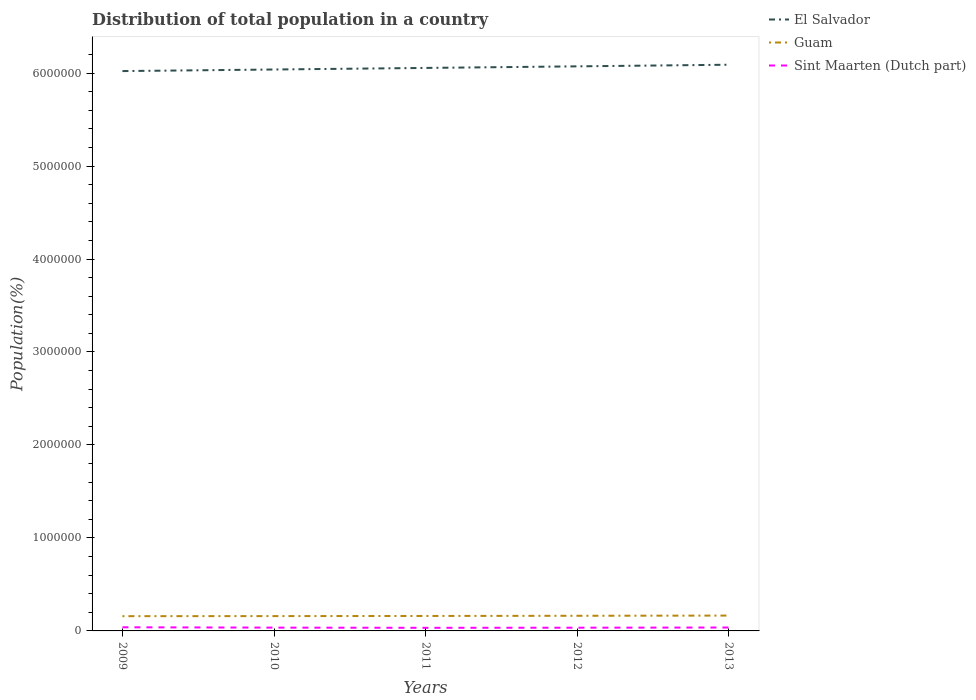How many different coloured lines are there?
Provide a succinct answer. 3. Is the number of lines equal to the number of legend labels?
Make the answer very short. Yes. Across all years, what is the maximum population of in El Salvador?
Keep it short and to the point. 6.02e+06. In which year was the population of in El Salvador maximum?
Your response must be concise. 2009. What is the total population of in Guam in the graph?
Offer a terse response. -4186. What is the difference between the highest and the second highest population of in Sint Maarten (Dutch part)?
Offer a very short reply. 5698. What is the difference between the highest and the lowest population of in El Salvador?
Your answer should be compact. 2. Is the population of in Sint Maarten (Dutch part) strictly greater than the population of in Guam over the years?
Give a very brief answer. Yes. What is the difference between two consecutive major ticks on the Y-axis?
Your response must be concise. 1.00e+06. Are the values on the major ticks of Y-axis written in scientific E-notation?
Keep it short and to the point. No. Where does the legend appear in the graph?
Provide a short and direct response. Top right. What is the title of the graph?
Offer a terse response. Distribution of total population in a country. Does "Saudi Arabia" appear as one of the legend labels in the graph?
Offer a terse response. No. What is the label or title of the Y-axis?
Your answer should be compact. Population(%). What is the Population(%) of El Salvador in 2009?
Your response must be concise. 6.02e+06. What is the Population(%) of Guam in 2009?
Offer a very short reply. 1.59e+05. What is the Population(%) of Sint Maarten (Dutch part) in 2009?
Give a very brief answer. 3.91e+04. What is the Population(%) in El Salvador in 2010?
Provide a short and direct response. 6.04e+06. What is the Population(%) in Guam in 2010?
Ensure brevity in your answer.  1.59e+05. What is the Population(%) of Sint Maarten (Dutch part) in 2010?
Offer a terse response. 3.55e+04. What is the Population(%) of El Salvador in 2011?
Make the answer very short. 6.06e+06. What is the Population(%) in Guam in 2011?
Provide a short and direct response. 1.61e+05. What is the Population(%) in Sint Maarten (Dutch part) in 2011?
Your answer should be very brief. 3.34e+04. What is the Population(%) in El Salvador in 2012?
Keep it short and to the point. 6.07e+06. What is the Population(%) of Guam in 2012?
Your answer should be compact. 1.63e+05. What is the Population(%) in Sint Maarten (Dutch part) in 2012?
Ensure brevity in your answer.  3.46e+04. What is the Population(%) in El Salvador in 2013?
Ensure brevity in your answer.  6.09e+06. What is the Population(%) of Guam in 2013?
Your answer should be compact. 1.65e+05. What is the Population(%) in Sint Maarten (Dutch part) in 2013?
Provide a short and direct response. 3.66e+04. Across all years, what is the maximum Population(%) of El Salvador?
Offer a terse response. 6.09e+06. Across all years, what is the maximum Population(%) of Guam?
Provide a short and direct response. 1.65e+05. Across all years, what is the maximum Population(%) of Sint Maarten (Dutch part)?
Your answer should be very brief. 3.91e+04. Across all years, what is the minimum Population(%) of El Salvador?
Give a very brief answer. 6.02e+06. Across all years, what is the minimum Population(%) of Guam?
Provide a short and direct response. 1.59e+05. Across all years, what is the minimum Population(%) in Sint Maarten (Dutch part)?
Keep it short and to the point. 3.34e+04. What is the total Population(%) of El Salvador in the graph?
Your response must be concise. 3.03e+07. What is the total Population(%) of Guam in the graph?
Your response must be concise. 8.07e+05. What is the total Population(%) of Sint Maarten (Dutch part) in the graph?
Your response must be concise. 1.79e+05. What is the difference between the Population(%) of El Salvador in 2009 and that in 2010?
Give a very brief answer. -1.69e+04. What is the difference between the Population(%) in Guam in 2009 and that in 2010?
Ensure brevity in your answer.  -819. What is the difference between the Population(%) of Sint Maarten (Dutch part) in 2009 and that in 2010?
Your response must be concise. 3659. What is the difference between the Population(%) in El Salvador in 2009 and that in 2011?
Offer a terse response. -3.38e+04. What is the difference between the Population(%) in Guam in 2009 and that in 2011?
Offer a terse response. -2237. What is the difference between the Population(%) in Sint Maarten (Dutch part) in 2009 and that in 2011?
Ensure brevity in your answer.  5698. What is the difference between the Population(%) of El Salvador in 2009 and that in 2012?
Offer a terse response. -5.09e+04. What is the difference between the Population(%) in Guam in 2009 and that in 2012?
Your answer should be very brief. -4186. What is the difference between the Population(%) in Sint Maarten (Dutch part) in 2009 and that in 2012?
Provide a short and direct response. 4493. What is the difference between the Population(%) in El Salvador in 2009 and that in 2013?
Offer a very short reply. -6.83e+04. What is the difference between the Population(%) in Guam in 2009 and that in 2013?
Offer a very short reply. -6500. What is the difference between the Population(%) of Sint Maarten (Dutch part) in 2009 and that in 2013?
Your answer should be compact. 2526. What is the difference between the Population(%) in El Salvador in 2010 and that in 2011?
Offer a terse response. -1.69e+04. What is the difference between the Population(%) in Guam in 2010 and that in 2011?
Offer a very short reply. -1418. What is the difference between the Population(%) in Sint Maarten (Dutch part) in 2010 and that in 2011?
Provide a short and direct response. 2039. What is the difference between the Population(%) in El Salvador in 2010 and that in 2012?
Your answer should be compact. -3.39e+04. What is the difference between the Population(%) in Guam in 2010 and that in 2012?
Provide a succinct answer. -3367. What is the difference between the Population(%) of Sint Maarten (Dutch part) in 2010 and that in 2012?
Your response must be concise. 834. What is the difference between the Population(%) in El Salvador in 2010 and that in 2013?
Give a very brief answer. -5.13e+04. What is the difference between the Population(%) in Guam in 2010 and that in 2013?
Your answer should be very brief. -5681. What is the difference between the Population(%) of Sint Maarten (Dutch part) in 2010 and that in 2013?
Provide a short and direct response. -1133. What is the difference between the Population(%) of El Salvador in 2011 and that in 2012?
Make the answer very short. -1.70e+04. What is the difference between the Population(%) of Guam in 2011 and that in 2012?
Give a very brief answer. -1949. What is the difference between the Population(%) of Sint Maarten (Dutch part) in 2011 and that in 2012?
Your response must be concise. -1205. What is the difference between the Population(%) in El Salvador in 2011 and that in 2013?
Make the answer very short. -3.44e+04. What is the difference between the Population(%) in Guam in 2011 and that in 2013?
Make the answer very short. -4263. What is the difference between the Population(%) of Sint Maarten (Dutch part) in 2011 and that in 2013?
Provide a succinct answer. -3172. What is the difference between the Population(%) of El Salvador in 2012 and that in 2013?
Your response must be concise. -1.74e+04. What is the difference between the Population(%) of Guam in 2012 and that in 2013?
Offer a terse response. -2314. What is the difference between the Population(%) of Sint Maarten (Dutch part) in 2012 and that in 2013?
Ensure brevity in your answer.  -1967. What is the difference between the Population(%) of El Salvador in 2009 and the Population(%) of Guam in 2010?
Make the answer very short. 5.86e+06. What is the difference between the Population(%) of El Salvador in 2009 and the Population(%) of Sint Maarten (Dutch part) in 2010?
Ensure brevity in your answer.  5.99e+06. What is the difference between the Population(%) of Guam in 2009 and the Population(%) of Sint Maarten (Dutch part) in 2010?
Offer a terse response. 1.23e+05. What is the difference between the Population(%) of El Salvador in 2009 and the Population(%) of Guam in 2011?
Make the answer very short. 5.86e+06. What is the difference between the Population(%) of El Salvador in 2009 and the Population(%) of Sint Maarten (Dutch part) in 2011?
Give a very brief answer. 5.99e+06. What is the difference between the Population(%) of Guam in 2009 and the Population(%) of Sint Maarten (Dutch part) in 2011?
Offer a very short reply. 1.25e+05. What is the difference between the Population(%) in El Salvador in 2009 and the Population(%) in Guam in 2012?
Provide a succinct answer. 5.86e+06. What is the difference between the Population(%) of El Salvador in 2009 and the Population(%) of Sint Maarten (Dutch part) in 2012?
Offer a terse response. 5.99e+06. What is the difference between the Population(%) of Guam in 2009 and the Population(%) of Sint Maarten (Dutch part) in 2012?
Provide a succinct answer. 1.24e+05. What is the difference between the Population(%) in El Salvador in 2009 and the Population(%) in Guam in 2013?
Your answer should be compact. 5.86e+06. What is the difference between the Population(%) in El Salvador in 2009 and the Population(%) in Sint Maarten (Dutch part) in 2013?
Offer a very short reply. 5.98e+06. What is the difference between the Population(%) in Guam in 2009 and the Population(%) in Sint Maarten (Dutch part) in 2013?
Your answer should be compact. 1.22e+05. What is the difference between the Population(%) of El Salvador in 2010 and the Population(%) of Guam in 2011?
Provide a succinct answer. 5.88e+06. What is the difference between the Population(%) in El Salvador in 2010 and the Population(%) in Sint Maarten (Dutch part) in 2011?
Provide a short and direct response. 6.00e+06. What is the difference between the Population(%) of Guam in 2010 and the Population(%) of Sint Maarten (Dutch part) in 2011?
Give a very brief answer. 1.26e+05. What is the difference between the Population(%) of El Salvador in 2010 and the Population(%) of Guam in 2012?
Provide a succinct answer. 5.88e+06. What is the difference between the Population(%) of El Salvador in 2010 and the Population(%) of Sint Maarten (Dutch part) in 2012?
Your response must be concise. 6.00e+06. What is the difference between the Population(%) in Guam in 2010 and the Population(%) in Sint Maarten (Dutch part) in 2012?
Offer a very short reply. 1.25e+05. What is the difference between the Population(%) of El Salvador in 2010 and the Population(%) of Guam in 2013?
Your response must be concise. 5.87e+06. What is the difference between the Population(%) of El Salvador in 2010 and the Population(%) of Sint Maarten (Dutch part) in 2013?
Ensure brevity in your answer.  6.00e+06. What is the difference between the Population(%) of Guam in 2010 and the Population(%) of Sint Maarten (Dutch part) in 2013?
Your answer should be very brief. 1.23e+05. What is the difference between the Population(%) of El Salvador in 2011 and the Population(%) of Guam in 2012?
Make the answer very short. 5.89e+06. What is the difference between the Population(%) of El Salvador in 2011 and the Population(%) of Sint Maarten (Dutch part) in 2012?
Your response must be concise. 6.02e+06. What is the difference between the Population(%) in Guam in 2011 and the Population(%) in Sint Maarten (Dutch part) in 2012?
Offer a very short reply. 1.26e+05. What is the difference between the Population(%) in El Salvador in 2011 and the Population(%) in Guam in 2013?
Ensure brevity in your answer.  5.89e+06. What is the difference between the Population(%) in El Salvador in 2011 and the Population(%) in Sint Maarten (Dutch part) in 2013?
Your response must be concise. 6.02e+06. What is the difference between the Population(%) in Guam in 2011 and the Population(%) in Sint Maarten (Dutch part) in 2013?
Make the answer very short. 1.24e+05. What is the difference between the Population(%) in El Salvador in 2012 and the Population(%) in Guam in 2013?
Provide a succinct answer. 5.91e+06. What is the difference between the Population(%) in El Salvador in 2012 and the Population(%) in Sint Maarten (Dutch part) in 2013?
Offer a terse response. 6.04e+06. What is the difference between the Population(%) of Guam in 2012 and the Population(%) of Sint Maarten (Dutch part) in 2013?
Provide a short and direct response. 1.26e+05. What is the average Population(%) of El Salvador per year?
Offer a terse response. 6.06e+06. What is the average Population(%) in Guam per year?
Give a very brief answer. 1.61e+05. What is the average Population(%) of Sint Maarten (Dutch part) per year?
Give a very brief answer. 3.59e+04. In the year 2009, what is the difference between the Population(%) in El Salvador and Population(%) in Guam?
Your answer should be very brief. 5.86e+06. In the year 2009, what is the difference between the Population(%) in El Salvador and Population(%) in Sint Maarten (Dutch part)?
Provide a short and direct response. 5.98e+06. In the year 2009, what is the difference between the Population(%) of Guam and Population(%) of Sint Maarten (Dutch part)?
Give a very brief answer. 1.19e+05. In the year 2010, what is the difference between the Population(%) of El Salvador and Population(%) of Guam?
Your answer should be very brief. 5.88e+06. In the year 2010, what is the difference between the Population(%) of El Salvador and Population(%) of Sint Maarten (Dutch part)?
Provide a short and direct response. 6.00e+06. In the year 2010, what is the difference between the Population(%) in Guam and Population(%) in Sint Maarten (Dutch part)?
Provide a succinct answer. 1.24e+05. In the year 2011, what is the difference between the Population(%) of El Salvador and Population(%) of Guam?
Keep it short and to the point. 5.89e+06. In the year 2011, what is the difference between the Population(%) of El Salvador and Population(%) of Sint Maarten (Dutch part)?
Keep it short and to the point. 6.02e+06. In the year 2011, what is the difference between the Population(%) in Guam and Population(%) in Sint Maarten (Dutch part)?
Your response must be concise. 1.27e+05. In the year 2012, what is the difference between the Population(%) in El Salvador and Population(%) in Guam?
Your answer should be compact. 5.91e+06. In the year 2012, what is the difference between the Population(%) of El Salvador and Population(%) of Sint Maarten (Dutch part)?
Your answer should be compact. 6.04e+06. In the year 2012, what is the difference between the Population(%) in Guam and Population(%) in Sint Maarten (Dutch part)?
Your answer should be compact. 1.28e+05. In the year 2013, what is the difference between the Population(%) in El Salvador and Population(%) in Guam?
Give a very brief answer. 5.92e+06. In the year 2013, what is the difference between the Population(%) of El Salvador and Population(%) of Sint Maarten (Dutch part)?
Offer a terse response. 6.05e+06. In the year 2013, what is the difference between the Population(%) of Guam and Population(%) of Sint Maarten (Dutch part)?
Make the answer very short. 1.29e+05. What is the ratio of the Population(%) of El Salvador in 2009 to that in 2010?
Your answer should be very brief. 1. What is the ratio of the Population(%) in Guam in 2009 to that in 2010?
Offer a terse response. 0.99. What is the ratio of the Population(%) in Sint Maarten (Dutch part) in 2009 to that in 2010?
Your response must be concise. 1.1. What is the ratio of the Population(%) of Guam in 2009 to that in 2011?
Provide a short and direct response. 0.99. What is the ratio of the Population(%) in Sint Maarten (Dutch part) in 2009 to that in 2011?
Keep it short and to the point. 1.17. What is the ratio of the Population(%) in Guam in 2009 to that in 2012?
Ensure brevity in your answer.  0.97. What is the ratio of the Population(%) of Sint Maarten (Dutch part) in 2009 to that in 2012?
Give a very brief answer. 1.13. What is the ratio of the Population(%) of Guam in 2009 to that in 2013?
Offer a very short reply. 0.96. What is the ratio of the Population(%) of Sint Maarten (Dutch part) in 2009 to that in 2013?
Ensure brevity in your answer.  1.07. What is the ratio of the Population(%) of Guam in 2010 to that in 2011?
Provide a succinct answer. 0.99. What is the ratio of the Population(%) in Sint Maarten (Dutch part) in 2010 to that in 2011?
Provide a short and direct response. 1.06. What is the ratio of the Population(%) in El Salvador in 2010 to that in 2012?
Your answer should be very brief. 0.99. What is the ratio of the Population(%) of Guam in 2010 to that in 2012?
Ensure brevity in your answer.  0.98. What is the ratio of the Population(%) in Sint Maarten (Dutch part) in 2010 to that in 2012?
Offer a terse response. 1.02. What is the ratio of the Population(%) in Guam in 2010 to that in 2013?
Your answer should be very brief. 0.97. What is the ratio of the Population(%) in Sint Maarten (Dutch part) in 2011 to that in 2012?
Your response must be concise. 0.97. What is the ratio of the Population(%) in Guam in 2011 to that in 2013?
Provide a succinct answer. 0.97. What is the ratio of the Population(%) in Sint Maarten (Dutch part) in 2011 to that in 2013?
Give a very brief answer. 0.91. What is the ratio of the Population(%) of El Salvador in 2012 to that in 2013?
Keep it short and to the point. 1. What is the ratio of the Population(%) of Guam in 2012 to that in 2013?
Keep it short and to the point. 0.99. What is the ratio of the Population(%) of Sint Maarten (Dutch part) in 2012 to that in 2013?
Give a very brief answer. 0.95. What is the difference between the highest and the second highest Population(%) of El Salvador?
Offer a terse response. 1.74e+04. What is the difference between the highest and the second highest Population(%) in Guam?
Offer a very short reply. 2314. What is the difference between the highest and the second highest Population(%) in Sint Maarten (Dutch part)?
Give a very brief answer. 2526. What is the difference between the highest and the lowest Population(%) of El Salvador?
Keep it short and to the point. 6.83e+04. What is the difference between the highest and the lowest Population(%) of Guam?
Your answer should be very brief. 6500. What is the difference between the highest and the lowest Population(%) of Sint Maarten (Dutch part)?
Keep it short and to the point. 5698. 